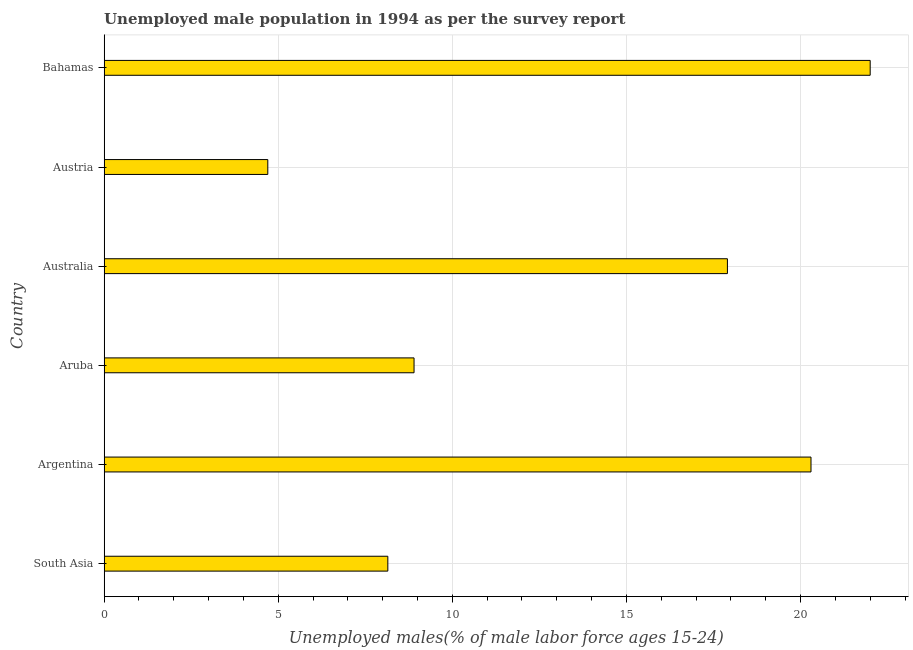Does the graph contain grids?
Your response must be concise. Yes. What is the title of the graph?
Make the answer very short. Unemployed male population in 1994 as per the survey report. What is the label or title of the X-axis?
Ensure brevity in your answer.  Unemployed males(% of male labor force ages 15-24). Across all countries, what is the maximum unemployed male youth?
Offer a very short reply. 22. Across all countries, what is the minimum unemployed male youth?
Provide a succinct answer. 4.7. In which country was the unemployed male youth maximum?
Give a very brief answer. Bahamas. In which country was the unemployed male youth minimum?
Your answer should be very brief. Austria. What is the sum of the unemployed male youth?
Ensure brevity in your answer.  81.95. What is the difference between the unemployed male youth in Austria and Bahamas?
Give a very brief answer. -17.3. What is the average unemployed male youth per country?
Provide a succinct answer. 13.66. What is the median unemployed male youth?
Your answer should be compact. 13.4. What is the ratio of the unemployed male youth in Argentina to that in Aruba?
Offer a terse response. 2.28. Is the difference between the unemployed male youth in Australia and South Asia greater than the difference between any two countries?
Give a very brief answer. No. In how many countries, is the unemployed male youth greater than the average unemployed male youth taken over all countries?
Provide a short and direct response. 3. Are all the bars in the graph horizontal?
Your answer should be compact. Yes. What is the Unemployed males(% of male labor force ages 15-24) of South Asia?
Make the answer very short. 8.15. What is the Unemployed males(% of male labor force ages 15-24) of Argentina?
Offer a terse response. 20.3. What is the Unemployed males(% of male labor force ages 15-24) of Aruba?
Your answer should be compact. 8.9. What is the Unemployed males(% of male labor force ages 15-24) of Australia?
Make the answer very short. 17.9. What is the Unemployed males(% of male labor force ages 15-24) of Austria?
Keep it short and to the point. 4.7. What is the Unemployed males(% of male labor force ages 15-24) in Bahamas?
Make the answer very short. 22. What is the difference between the Unemployed males(% of male labor force ages 15-24) in South Asia and Argentina?
Your answer should be very brief. -12.15. What is the difference between the Unemployed males(% of male labor force ages 15-24) in South Asia and Aruba?
Keep it short and to the point. -0.75. What is the difference between the Unemployed males(% of male labor force ages 15-24) in South Asia and Australia?
Make the answer very short. -9.75. What is the difference between the Unemployed males(% of male labor force ages 15-24) in South Asia and Austria?
Your response must be concise. 3.45. What is the difference between the Unemployed males(% of male labor force ages 15-24) in South Asia and Bahamas?
Give a very brief answer. -13.85. What is the difference between the Unemployed males(% of male labor force ages 15-24) in Argentina and Aruba?
Your answer should be very brief. 11.4. What is the difference between the Unemployed males(% of male labor force ages 15-24) in Aruba and Australia?
Offer a very short reply. -9. What is the difference between the Unemployed males(% of male labor force ages 15-24) in Aruba and Austria?
Offer a terse response. 4.2. What is the difference between the Unemployed males(% of male labor force ages 15-24) in Australia and Austria?
Provide a short and direct response. 13.2. What is the difference between the Unemployed males(% of male labor force ages 15-24) in Australia and Bahamas?
Give a very brief answer. -4.1. What is the difference between the Unemployed males(% of male labor force ages 15-24) in Austria and Bahamas?
Offer a terse response. -17.3. What is the ratio of the Unemployed males(% of male labor force ages 15-24) in South Asia to that in Argentina?
Your answer should be very brief. 0.4. What is the ratio of the Unemployed males(% of male labor force ages 15-24) in South Asia to that in Aruba?
Your answer should be compact. 0.92. What is the ratio of the Unemployed males(% of male labor force ages 15-24) in South Asia to that in Australia?
Your answer should be very brief. 0.46. What is the ratio of the Unemployed males(% of male labor force ages 15-24) in South Asia to that in Austria?
Ensure brevity in your answer.  1.73. What is the ratio of the Unemployed males(% of male labor force ages 15-24) in South Asia to that in Bahamas?
Your response must be concise. 0.37. What is the ratio of the Unemployed males(% of male labor force ages 15-24) in Argentina to that in Aruba?
Give a very brief answer. 2.28. What is the ratio of the Unemployed males(% of male labor force ages 15-24) in Argentina to that in Australia?
Give a very brief answer. 1.13. What is the ratio of the Unemployed males(% of male labor force ages 15-24) in Argentina to that in Austria?
Offer a very short reply. 4.32. What is the ratio of the Unemployed males(% of male labor force ages 15-24) in Argentina to that in Bahamas?
Make the answer very short. 0.92. What is the ratio of the Unemployed males(% of male labor force ages 15-24) in Aruba to that in Australia?
Your answer should be compact. 0.5. What is the ratio of the Unemployed males(% of male labor force ages 15-24) in Aruba to that in Austria?
Provide a short and direct response. 1.89. What is the ratio of the Unemployed males(% of male labor force ages 15-24) in Aruba to that in Bahamas?
Your answer should be compact. 0.41. What is the ratio of the Unemployed males(% of male labor force ages 15-24) in Australia to that in Austria?
Your answer should be very brief. 3.81. What is the ratio of the Unemployed males(% of male labor force ages 15-24) in Australia to that in Bahamas?
Offer a very short reply. 0.81. What is the ratio of the Unemployed males(% of male labor force ages 15-24) in Austria to that in Bahamas?
Offer a terse response. 0.21. 